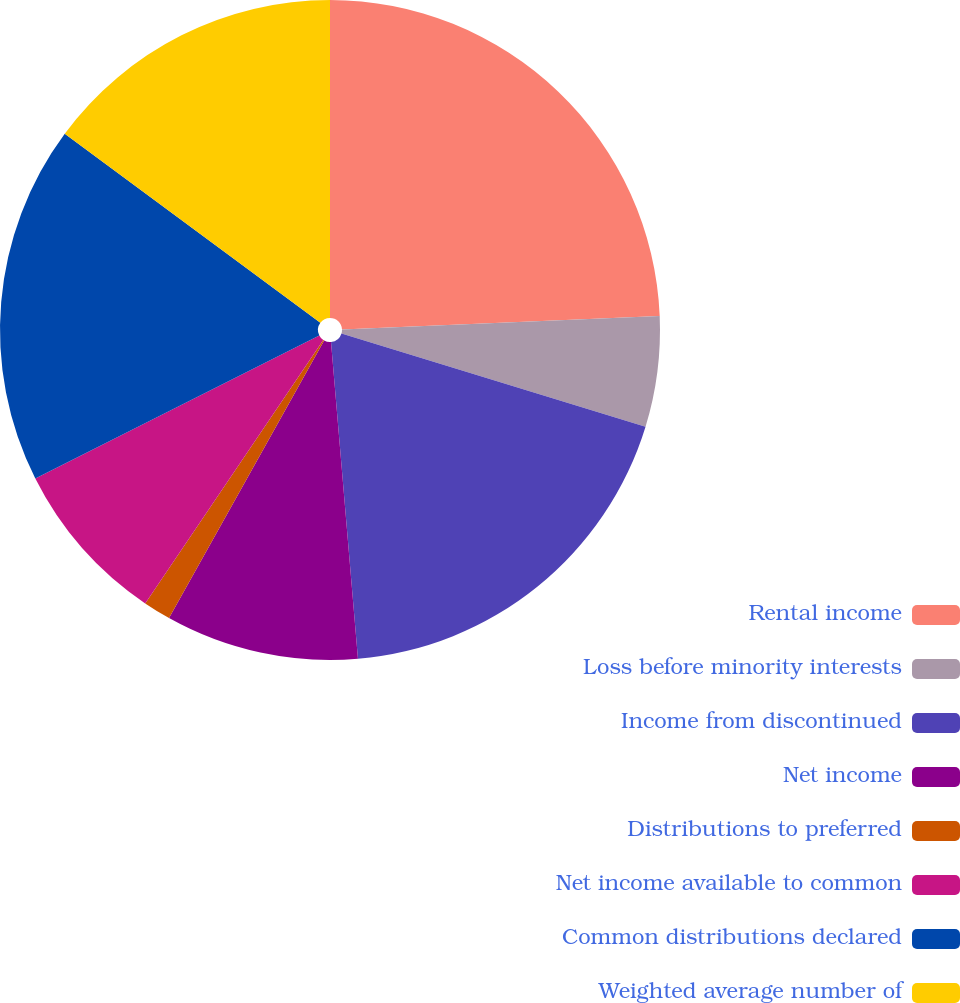Convert chart to OTSL. <chart><loc_0><loc_0><loc_500><loc_500><pie_chart><fcel>Rental income<fcel>Loss before minority interests<fcel>Income from discontinued<fcel>Net income<fcel>Distributions to preferred<fcel>Net income available to common<fcel>Common distributions declared<fcel>Weighted average number of<nl><fcel>24.32%<fcel>5.41%<fcel>18.92%<fcel>9.46%<fcel>1.35%<fcel>8.11%<fcel>17.57%<fcel>14.86%<nl></chart> 